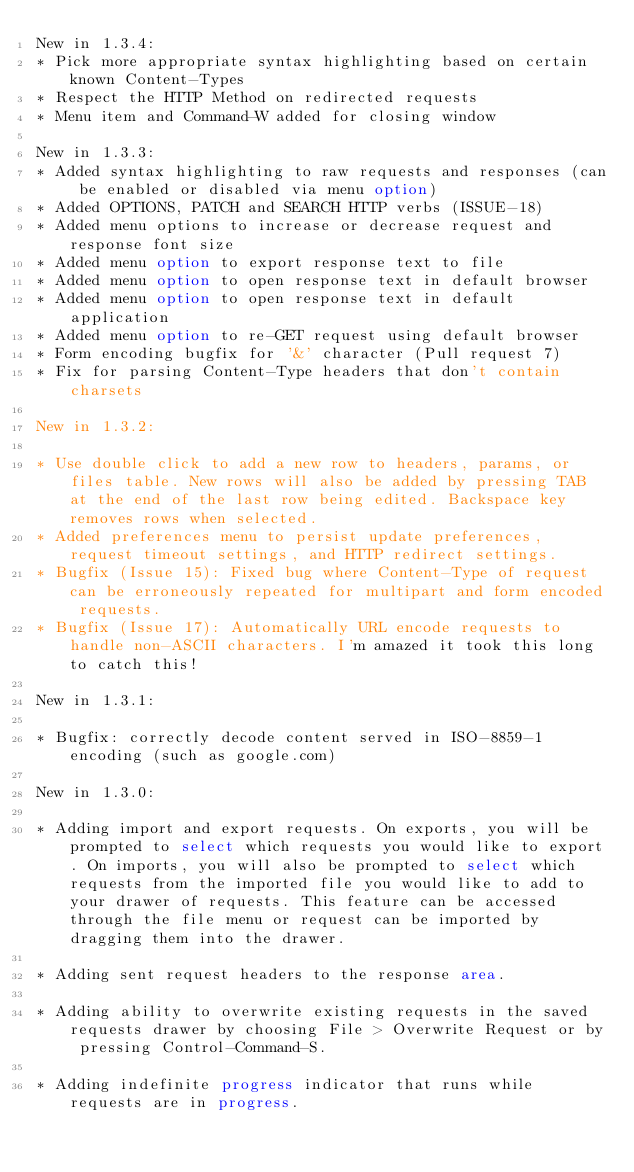<code> <loc_0><loc_0><loc_500><loc_500><_HTML_>New in 1.3.4:
* Pick more appropriate syntax highlighting based on certain known Content-Types
* Respect the HTTP Method on redirected requests
* Menu item and Command-W added for closing window

New in 1.3.3:
* Added syntax highlighting to raw requests and responses (can be enabled or disabled via menu option)
* Added OPTIONS, PATCH and SEARCH HTTP verbs (ISSUE-18)
* Added menu options to increase or decrease request and response font size
* Added menu option to export response text to file
* Added menu option to open response text in default browser
* Added menu option to open response text in default application
* Added menu option to re-GET request using default browser
* Form encoding bugfix for '&' character (Pull request 7)
* Fix for parsing Content-Type headers that don't contain charsets

New in 1.3.2:

* Use double click to add a new row to headers, params, or files table. New rows will also be added by pressing TAB at the end of the last row being edited. Backspace key removes rows when selected.
* Added preferences menu to persist update preferences, request timeout settings, and HTTP redirect settings.
* Bugfix (Issue 15): Fixed bug where Content-Type of request can be erroneously repeated for multipart and form encoded requests.
* Bugfix (Issue 17): Automatically URL encode requests to handle non-ASCII characters. I'm amazed it took this long to catch this!

New in 1.3.1:

* Bugfix: correctly decode content served in ISO-8859-1 encoding (such as google.com)

New in 1.3.0:

* Adding import and export requests. On exports, you will be prompted to select which requests you would like to export. On imports, you will also be prompted to select which requests from the imported file you would like to add to your drawer of requests. This feature can be accessed through the file menu or request can be imported by dragging them into the drawer.

* Adding sent request headers to the response area.

* Adding ability to overwrite existing requests in the saved requests drawer by choosing File > Overwrite Request or by pressing Control-Command-S.

* Adding indefinite progress indicator that runs while requests are in progress.

</code> 